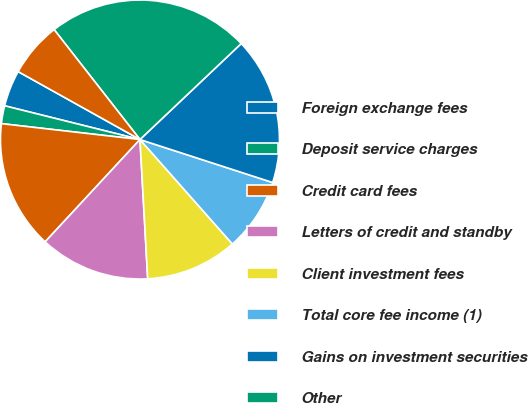<chart> <loc_0><loc_0><loc_500><loc_500><pie_chart><fcel>Foreign exchange fees<fcel>Deposit service charges<fcel>Credit card fees<fcel>Letters of credit and standby<fcel>Client investment fees<fcel>Total core fee income (1)<fcel>Gains on investment securities<fcel>Other<fcel>Total noninterest income<nl><fcel>4.21%<fcel>2.07%<fcel>14.92%<fcel>12.78%<fcel>10.64%<fcel>8.49%<fcel>17.06%<fcel>23.48%<fcel>6.35%<nl></chart> 